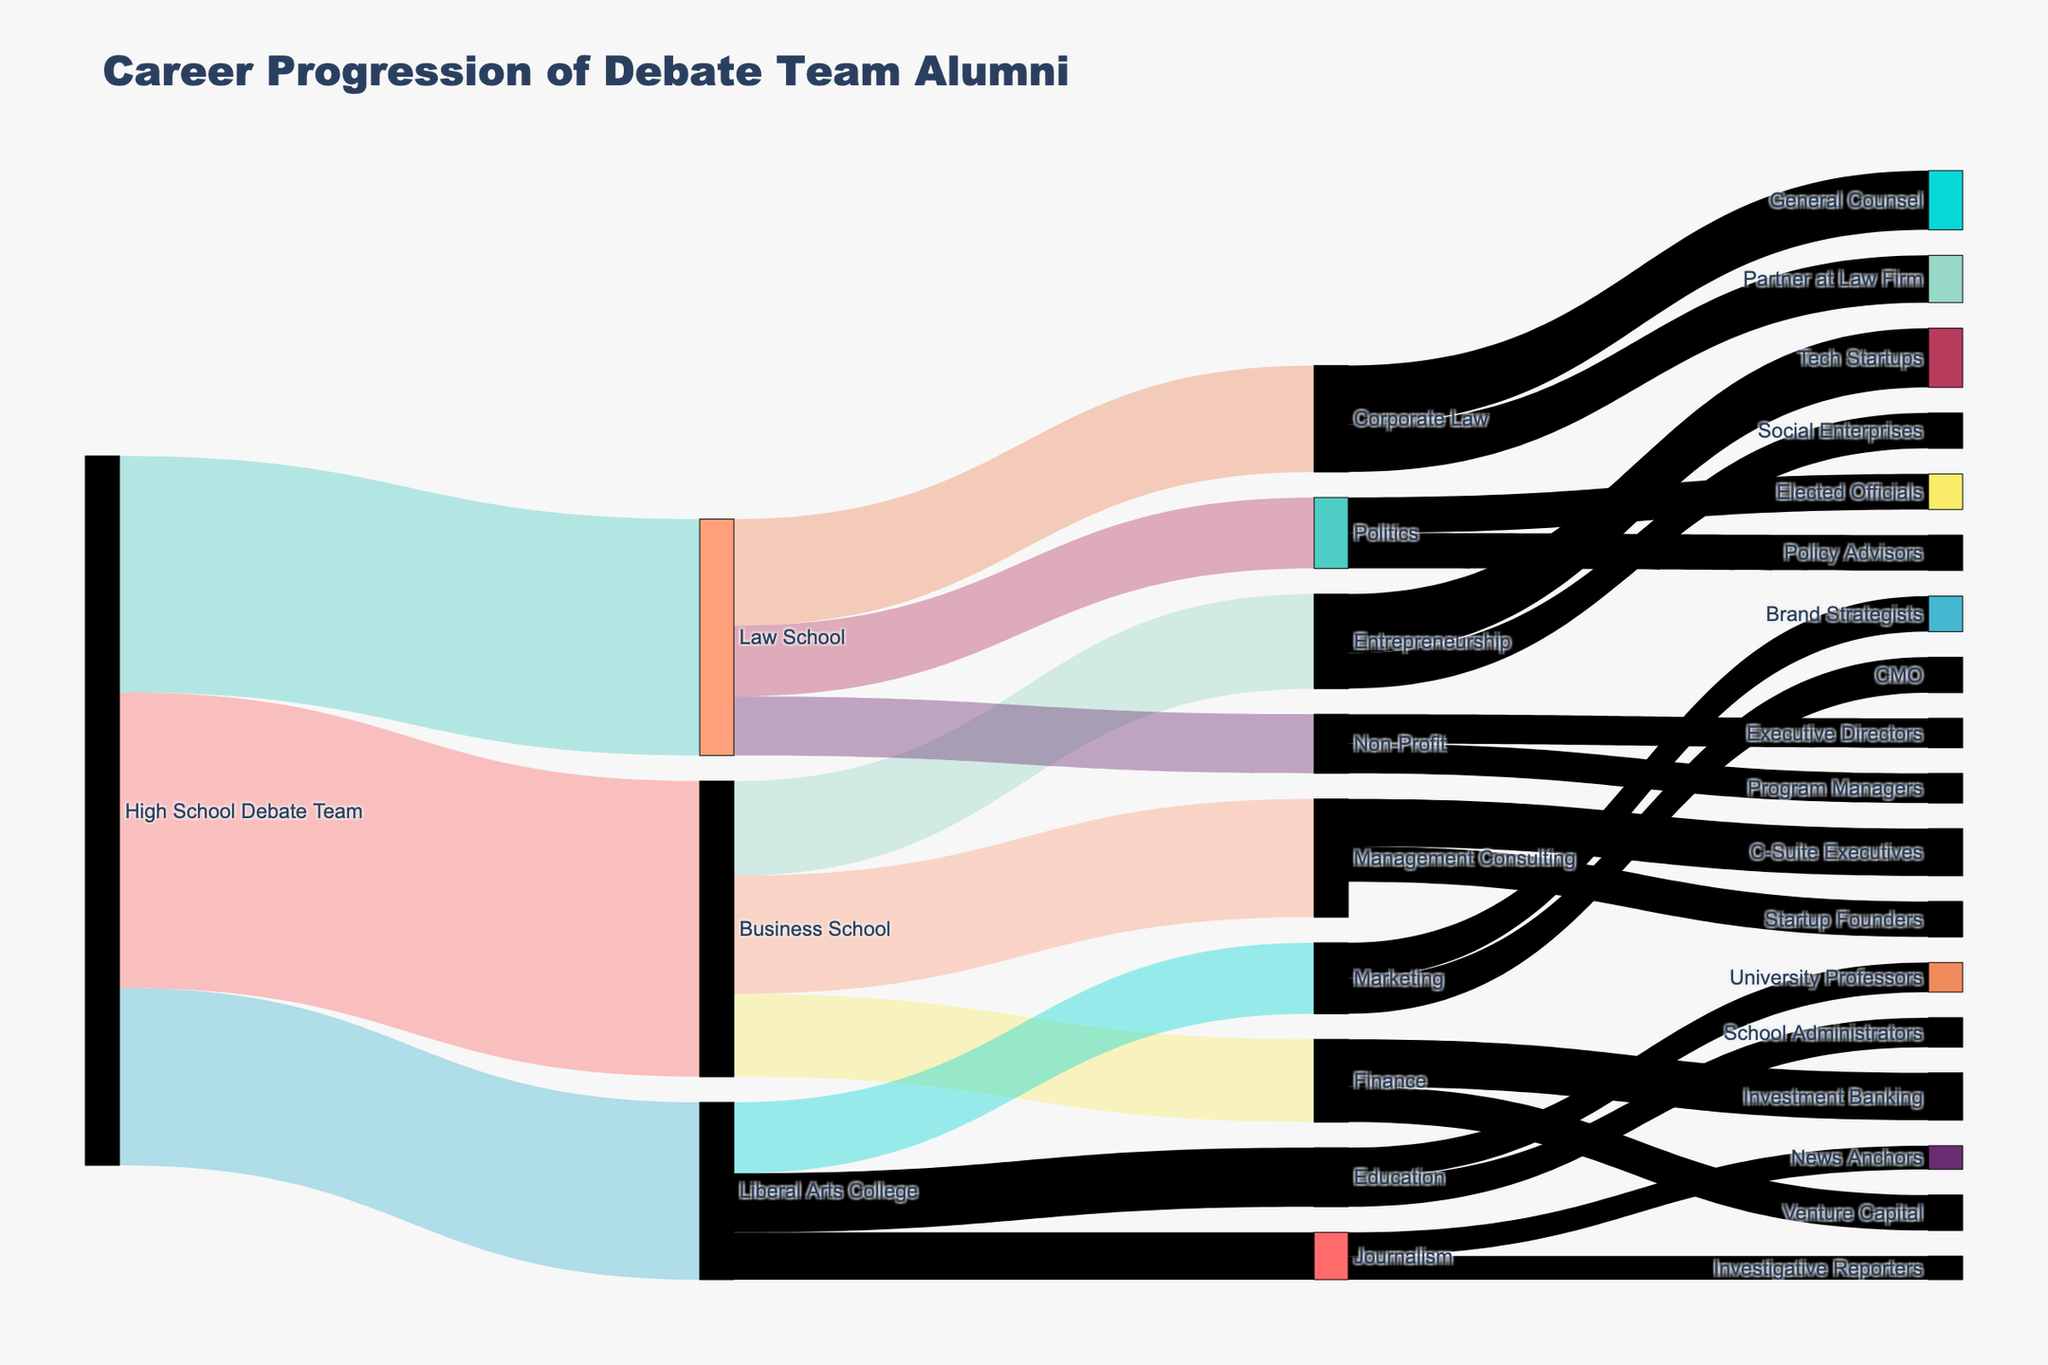How many alumni transitioned into Management Consulting after Business School? Refer to the diagram and see the link between Business School and Management Consulting, which should have a value associated with it.
Answer: 100 What is the overall number of alumni who went to Law School after High School Debate Team? Look at the total value flowing from High School Debate Team to Law School.
Answer: 200 Which industry has the highest number of business school alumni? Compare the connections from Business School to Management Consulting, Entrepreneurship, and Finance and identify the highest value.
Answer: Management Consulting What are the total number of alumni who ended up in Marketing from Liberal Arts College? Identify and sum the values of the connections flowing from Liberal Arts College to Marketing.
Answer: 60 How many Debate Team alumni pursued a career in Politics after attending Law School? Identify the link between Law School and Politics and note the value of this connection.
Answer: 60 What is the sum of alumni who went into Startup Founders and Tech Startups from Management Consulting and Entrepreneurship respectively? Add the values: Management Consulting to Startup Founders and Entrepreneurship to Tech Startups.
Answer: 30 + 50 = 80 What’s the total number of alumni that went into Social Enterprises and Non-Profit sectors from Entrepreneurship and Law School respectively? Sum the alumni numbers going from Entrepreneurship to Social Enterprises and Law School to Non-Profit.
Answer: 30 + 50 = 80 What’s the difference in alumni numbers between those who went into Investment Banking and Venture Capital from Finance? Subtract the value of the Venture Capital link from that of the Investment Banking link.
Answer: 40 - 30 = 10 From which path do most C-Suite Executives originate? Look for the highest value flow into the C-Suite Executives node and identify the originating path.
Answer: Management Consulting What is the combined total of alumni who pursued careers as General Counsel or Partners at Law Firms from Corporate Law? Add the number of alumni who pursued the careers General Counsel and Partner at Law Firm from Corporate Law.
Answer: 50 + 40 = 90 